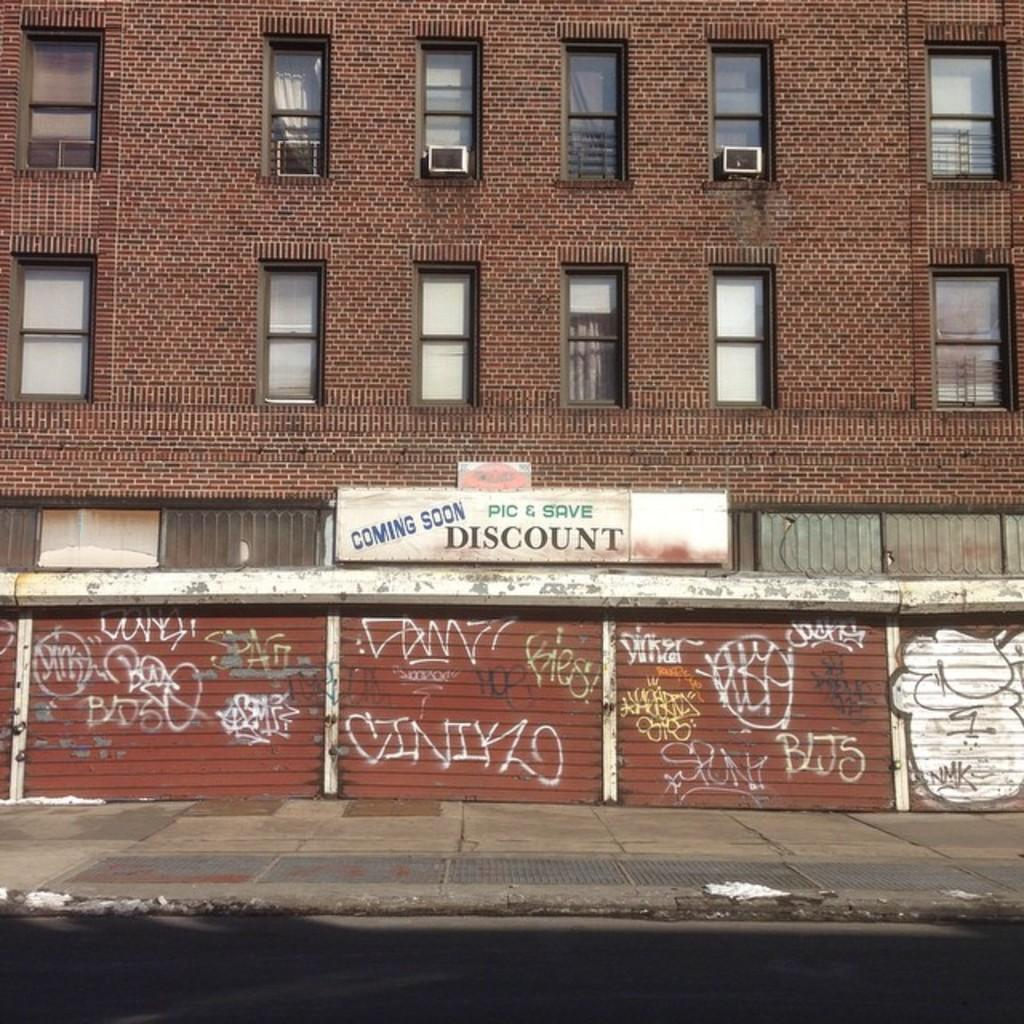What is the large sign in the image called? There is a hoarding in the image. What type of structure is present in the image? There is a building in the image. What devices are visible on the building? There are air conditioners visible in the image. What type of ice can be seen melting on the building in the image? There is no ice present in the image; it features a hoarding, a building, and air conditioners. What is the friction between the air conditioners and the building in the image? The concept of friction is not applicable to the image, as it is a physical property related to the interaction between two surfaces in contact. 